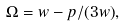<formula> <loc_0><loc_0><loc_500><loc_500>\Omega = w - p / ( 3 w ) ,</formula> 